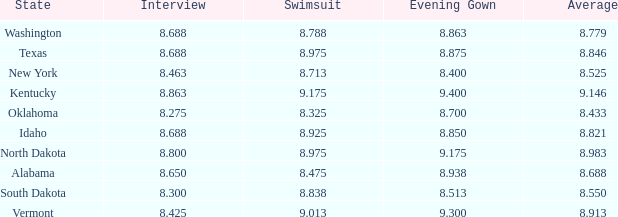What is the highest swimsuit score of the contestant with an evening gown larger than 9.175 and an interview score less than 8.425? None. 